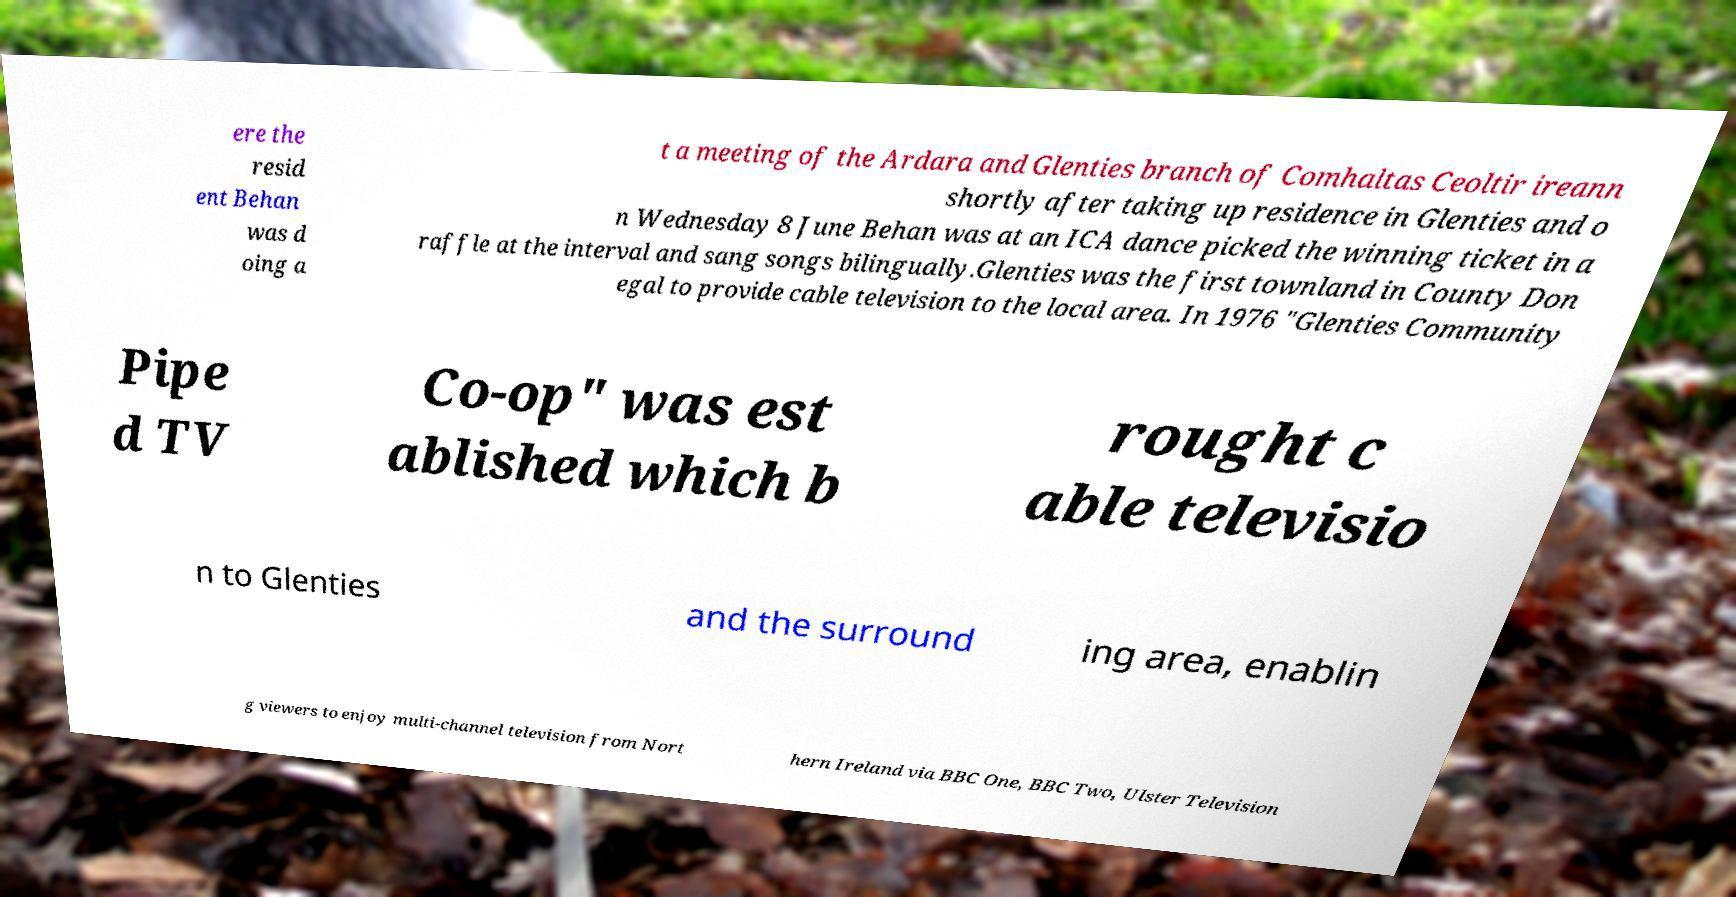I need the written content from this picture converted into text. Can you do that? ere the resid ent Behan was d oing a t a meeting of the Ardara and Glenties branch of Comhaltas Ceoltir ireann shortly after taking up residence in Glenties and o n Wednesday 8 June Behan was at an ICA dance picked the winning ticket in a raffle at the interval and sang songs bilingually.Glenties was the first townland in County Don egal to provide cable television to the local area. In 1976 "Glenties Community Pipe d TV Co-op" was est ablished which b rought c able televisio n to Glenties and the surround ing area, enablin g viewers to enjoy multi-channel television from Nort hern Ireland via BBC One, BBC Two, Ulster Television 